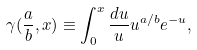Convert formula to latex. <formula><loc_0><loc_0><loc_500><loc_500>\gamma ( \frac { a } { b } , x ) \equiv \int ^ { x } _ { 0 } \frac { d u } { u } u ^ { a / b } e ^ { - u } ,</formula> 